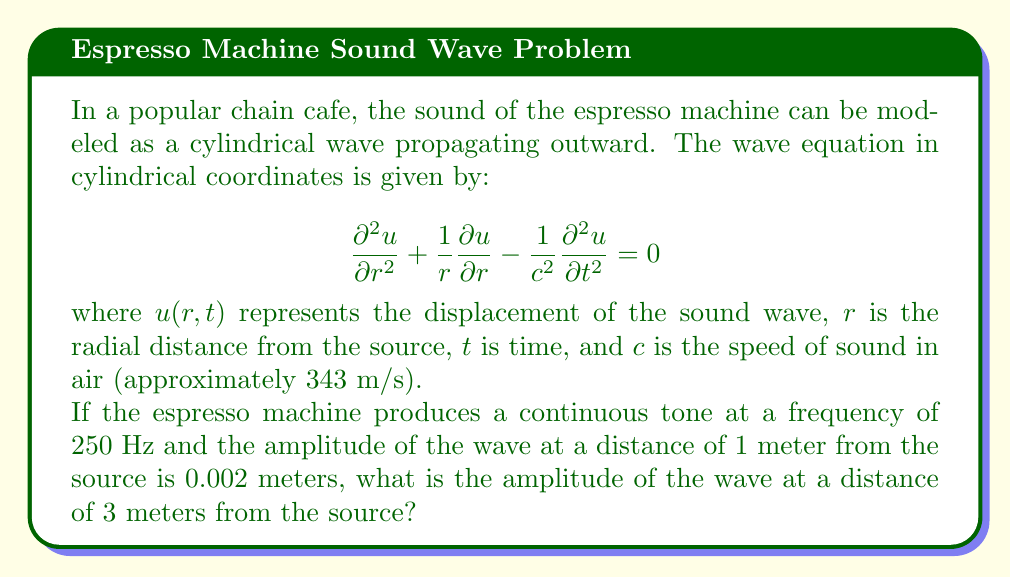What is the answer to this math problem? Let's approach this step-by-step:

1) For a cylindrical wave, the amplitude $A(r)$ is inversely proportional to the square root of the distance $r$ from the source. This relationship can be expressed as:

   $$A(r) = \frac{A_0}{\sqrt{r}}$$

   where $A_0$ is a constant.

2) We're given that at $r_1 = 1$ meter, the amplitude $A_1 = 0.002$ meters. We can use this to find $A_0$:

   $$0.002 = \frac{A_0}{\sqrt{1}}$$
   $$A_0 = 0.002$$

3) Now, we want to find the amplitude $A_2$ at $r_2 = 3$ meters. We can use the same equation:

   $$A_2 = \frac{A_0}{\sqrt{3}}$$

4) Substituting in our value for $A_0$:

   $$A_2 = \frac{0.002}{\sqrt{3}}$$

5) Simplifying:

   $$A_2 = \frac{0.002}{\sqrt{3}} \approx 0.001155 \text{ meters}$$

Thus, the amplitude of the wave at 3 meters from the source is approximately 0.001155 meters or 1.155 millimeters.
Answer: 0.001155 m 